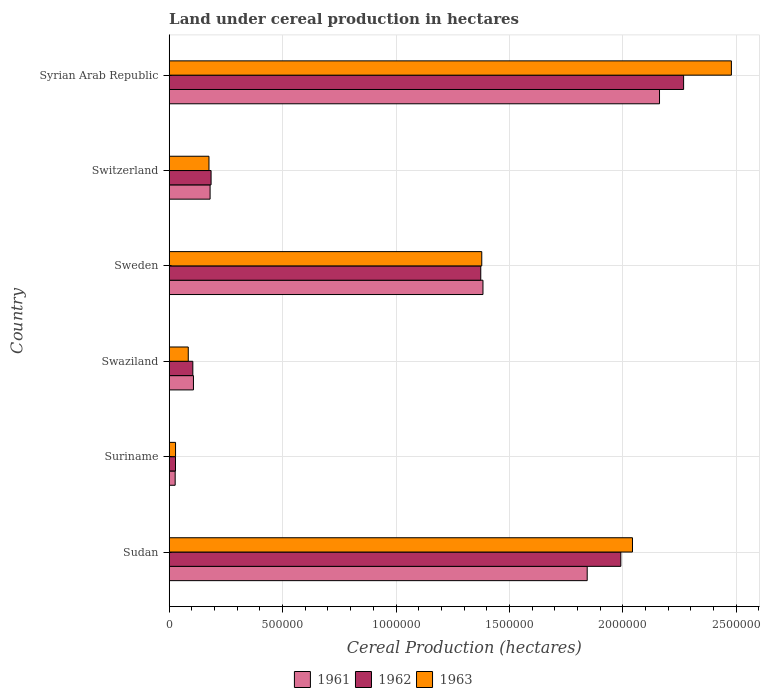How many groups of bars are there?
Give a very brief answer. 6. How many bars are there on the 4th tick from the bottom?
Offer a terse response. 3. What is the label of the 3rd group of bars from the top?
Provide a short and direct response. Sweden. What is the land under cereal production in 1963 in Suriname?
Offer a terse response. 2.79e+04. Across all countries, what is the maximum land under cereal production in 1962?
Make the answer very short. 2.27e+06. Across all countries, what is the minimum land under cereal production in 1963?
Make the answer very short. 2.79e+04. In which country was the land under cereal production in 1963 maximum?
Offer a very short reply. Syrian Arab Republic. In which country was the land under cereal production in 1963 minimum?
Give a very brief answer. Suriname. What is the total land under cereal production in 1963 in the graph?
Give a very brief answer. 6.19e+06. What is the difference between the land under cereal production in 1961 in Sweden and that in Switzerland?
Provide a succinct answer. 1.20e+06. What is the difference between the land under cereal production in 1962 in Syrian Arab Republic and the land under cereal production in 1963 in Sweden?
Offer a terse response. 8.90e+05. What is the average land under cereal production in 1961 per country?
Provide a succinct answer. 9.50e+05. What is the difference between the land under cereal production in 1961 and land under cereal production in 1963 in Suriname?
Give a very brief answer. -1608. In how many countries, is the land under cereal production in 1962 greater than 2000000 hectares?
Your response must be concise. 1. What is the ratio of the land under cereal production in 1962 in Swaziland to that in Syrian Arab Republic?
Keep it short and to the point. 0.05. Is the difference between the land under cereal production in 1961 in Sudan and Sweden greater than the difference between the land under cereal production in 1963 in Sudan and Sweden?
Provide a succinct answer. No. What is the difference between the highest and the second highest land under cereal production in 1961?
Offer a terse response. 3.19e+05. What is the difference between the highest and the lowest land under cereal production in 1961?
Give a very brief answer. 2.14e+06. In how many countries, is the land under cereal production in 1962 greater than the average land under cereal production in 1962 taken over all countries?
Your answer should be compact. 3. What does the 2nd bar from the top in Syrian Arab Republic represents?
Give a very brief answer. 1962. What does the 1st bar from the bottom in Syrian Arab Republic represents?
Your answer should be very brief. 1961. Is it the case that in every country, the sum of the land under cereal production in 1963 and land under cereal production in 1962 is greater than the land under cereal production in 1961?
Provide a succinct answer. Yes. Are all the bars in the graph horizontal?
Provide a short and direct response. Yes. Are the values on the major ticks of X-axis written in scientific E-notation?
Keep it short and to the point. No. Does the graph contain grids?
Make the answer very short. Yes. What is the title of the graph?
Make the answer very short. Land under cereal production in hectares. What is the label or title of the X-axis?
Offer a very short reply. Cereal Production (hectares). What is the label or title of the Y-axis?
Your response must be concise. Country. What is the Cereal Production (hectares) in 1961 in Sudan?
Ensure brevity in your answer.  1.84e+06. What is the Cereal Production (hectares) in 1962 in Sudan?
Your answer should be compact. 1.99e+06. What is the Cereal Production (hectares) of 1963 in Sudan?
Offer a terse response. 2.04e+06. What is the Cereal Production (hectares) of 1961 in Suriname?
Provide a short and direct response. 2.63e+04. What is the Cereal Production (hectares) in 1962 in Suriname?
Provide a short and direct response. 2.77e+04. What is the Cereal Production (hectares) of 1963 in Suriname?
Ensure brevity in your answer.  2.79e+04. What is the Cereal Production (hectares) of 1961 in Swaziland?
Your answer should be very brief. 1.07e+05. What is the Cereal Production (hectares) of 1962 in Swaziland?
Keep it short and to the point. 1.04e+05. What is the Cereal Production (hectares) in 1963 in Swaziland?
Your answer should be compact. 8.40e+04. What is the Cereal Production (hectares) of 1961 in Sweden?
Ensure brevity in your answer.  1.38e+06. What is the Cereal Production (hectares) of 1962 in Sweden?
Give a very brief answer. 1.37e+06. What is the Cereal Production (hectares) in 1963 in Sweden?
Offer a terse response. 1.38e+06. What is the Cereal Production (hectares) of 1961 in Switzerland?
Make the answer very short. 1.80e+05. What is the Cereal Production (hectares) of 1962 in Switzerland?
Keep it short and to the point. 1.85e+05. What is the Cereal Production (hectares) of 1963 in Switzerland?
Give a very brief answer. 1.75e+05. What is the Cereal Production (hectares) in 1961 in Syrian Arab Republic?
Your answer should be compact. 2.16e+06. What is the Cereal Production (hectares) in 1962 in Syrian Arab Republic?
Keep it short and to the point. 2.27e+06. What is the Cereal Production (hectares) of 1963 in Syrian Arab Republic?
Give a very brief answer. 2.48e+06. Across all countries, what is the maximum Cereal Production (hectares) of 1961?
Give a very brief answer. 2.16e+06. Across all countries, what is the maximum Cereal Production (hectares) of 1962?
Your answer should be compact. 2.27e+06. Across all countries, what is the maximum Cereal Production (hectares) in 1963?
Make the answer very short. 2.48e+06. Across all countries, what is the minimum Cereal Production (hectares) in 1961?
Ensure brevity in your answer.  2.63e+04. Across all countries, what is the minimum Cereal Production (hectares) in 1962?
Keep it short and to the point. 2.77e+04. Across all countries, what is the minimum Cereal Production (hectares) of 1963?
Your answer should be compact. 2.79e+04. What is the total Cereal Production (hectares) in 1961 in the graph?
Provide a succinct answer. 5.70e+06. What is the total Cereal Production (hectares) of 1962 in the graph?
Your answer should be very brief. 5.95e+06. What is the total Cereal Production (hectares) in 1963 in the graph?
Provide a succinct answer. 6.19e+06. What is the difference between the Cereal Production (hectares) of 1961 in Sudan and that in Suriname?
Offer a terse response. 1.82e+06. What is the difference between the Cereal Production (hectares) of 1962 in Sudan and that in Suriname?
Make the answer very short. 1.96e+06. What is the difference between the Cereal Production (hectares) in 1963 in Sudan and that in Suriname?
Offer a very short reply. 2.01e+06. What is the difference between the Cereal Production (hectares) in 1961 in Sudan and that in Swaziland?
Offer a very short reply. 1.74e+06. What is the difference between the Cereal Production (hectares) in 1962 in Sudan and that in Swaziland?
Your answer should be compact. 1.89e+06. What is the difference between the Cereal Production (hectares) in 1963 in Sudan and that in Swaziland?
Ensure brevity in your answer.  1.96e+06. What is the difference between the Cereal Production (hectares) of 1961 in Sudan and that in Sweden?
Give a very brief answer. 4.60e+05. What is the difference between the Cereal Production (hectares) of 1962 in Sudan and that in Sweden?
Give a very brief answer. 6.18e+05. What is the difference between the Cereal Production (hectares) in 1963 in Sudan and that in Sweden?
Keep it short and to the point. 6.65e+05. What is the difference between the Cereal Production (hectares) of 1961 in Sudan and that in Switzerland?
Offer a terse response. 1.66e+06. What is the difference between the Cereal Production (hectares) of 1962 in Sudan and that in Switzerland?
Provide a succinct answer. 1.81e+06. What is the difference between the Cereal Production (hectares) in 1963 in Sudan and that in Switzerland?
Your answer should be very brief. 1.87e+06. What is the difference between the Cereal Production (hectares) of 1961 in Sudan and that in Syrian Arab Republic?
Your answer should be very brief. -3.19e+05. What is the difference between the Cereal Production (hectares) in 1962 in Sudan and that in Syrian Arab Republic?
Your answer should be compact. -2.77e+05. What is the difference between the Cereal Production (hectares) of 1963 in Sudan and that in Syrian Arab Republic?
Offer a terse response. -4.36e+05. What is the difference between the Cereal Production (hectares) in 1961 in Suriname and that in Swaziland?
Offer a very short reply. -8.06e+04. What is the difference between the Cereal Production (hectares) of 1962 in Suriname and that in Swaziland?
Your answer should be very brief. -7.64e+04. What is the difference between the Cereal Production (hectares) of 1963 in Suriname and that in Swaziland?
Offer a terse response. -5.61e+04. What is the difference between the Cereal Production (hectares) in 1961 in Suriname and that in Sweden?
Your answer should be very brief. -1.36e+06. What is the difference between the Cereal Production (hectares) of 1962 in Suriname and that in Sweden?
Provide a short and direct response. -1.35e+06. What is the difference between the Cereal Production (hectares) of 1963 in Suriname and that in Sweden?
Offer a very short reply. -1.35e+06. What is the difference between the Cereal Production (hectares) in 1961 in Suriname and that in Switzerland?
Offer a terse response. -1.54e+05. What is the difference between the Cereal Production (hectares) in 1962 in Suriname and that in Switzerland?
Your answer should be very brief. -1.57e+05. What is the difference between the Cereal Production (hectares) of 1963 in Suriname and that in Switzerland?
Make the answer very short. -1.47e+05. What is the difference between the Cereal Production (hectares) of 1961 in Suriname and that in Syrian Arab Republic?
Provide a succinct answer. -2.14e+06. What is the difference between the Cereal Production (hectares) in 1962 in Suriname and that in Syrian Arab Republic?
Ensure brevity in your answer.  -2.24e+06. What is the difference between the Cereal Production (hectares) of 1963 in Suriname and that in Syrian Arab Republic?
Make the answer very short. -2.45e+06. What is the difference between the Cereal Production (hectares) of 1961 in Swaziland and that in Sweden?
Provide a short and direct response. -1.28e+06. What is the difference between the Cereal Production (hectares) in 1962 in Swaziland and that in Sweden?
Make the answer very short. -1.27e+06. What is the difference between the Cereal Production (hectares) in 1963 in Swaziland and that in Sweden?
Keep it short and to the point. -1.29e+06. What is the difference between the Cereal Production (hectares) of 1961 in Swaziland and that in Switzerland?
Offer a terse response. -7.34e+04. What is the difference between the Cereal Production (hectares) of 1962 in Swaziland and that in Switzerland?
Give a very brief answer. -8.05e+04. What is the difference between the Cereal Production (hectares) in 1963 in Swaziland and that in Switzerland?
Ensure brevity in your answer.  -9.13e+04. What is the difference between the Cereal Production (hectares) of 1961 in Swaziland and that in Syrian Arab Republic?
Provide a short and direct response. -2.05e+06. What is the difference between the Cereal Production (hectares) in 1962 in Swaziland and that in Syrian Arab Republic?
Keep it short and to the point. -2.16e+06. What is the difference between the Cereal Production (hectares) in 1963 in Swaziland and that in Syrian Arab Republic?
Provide a succinct answer. -2.39e+06. What is the difference between the Cereal Production (hectares) of 1961 in Sweden and that in Switzerland?
Provide a short and direct response. 1.20e+06. What is the difference between the Cereal Production (hectares) of 1962 in Sweden and that in Switzerland?
Give a very brief answer. 1.19e+06. What is the difference between the Cereal Production (hectares) of 1963 in Sweden and that in Switzerland?
Make the answer very short. 1.20e+06. What is the difference between the Cereal Production (hectares) of 1961 in Sweden and that in Syrian Arab Republic?
Provide a succinct answer. -7.78e+05. What is the difference between the Cereal Production (hectares) in 1962 in Sweden and that in Syrian Arab Republic?
Provide a short and direct response. -8.94e+05. What is the difference between the Cereal Production (hectares) of 1963 in Sweden and that in Syrian Arab Republic?
Offer a very short reply. -1.10e+06. What is the difference between the Cereal Production (hectares) in 1961 in Switzerland and that in Syrian Arab Republic?
Your answer should be very brief. -1.98e+06. What is the difference between the Cereal Production (hectares) in 1962 in Switzerland and that in Syrian Arab Republic?
Provide a succinct answer. -2.08e+06. What is the difference between the Cereal Production (hectares) in 1963 in Switzerland and that in Syrian Arab Republic?
Offer a very short reply. -2.30e+06. What is the difference between the Cereal Production (hectares) in 1961 in Sudan and the Cereal Production (hectares) in 1962 in Suriname?
Provide a short and direct response. 1.82e+06. What is the difference between the Cereal Production (hectares) in 1961 in Sudan and the Cereal Production (hectares) in 1963 in Suriname?
Provide a short and direct response. 1.82e+06. What is the difference between the Cereal Production (hectares) in 1962 in Sudan and the Cereal Production (hectares) in 1963 in Suriname?
Offer a terse response. 1.96e+06. What is the difference between the Cereal Production (hectares) of 1961 in Sudan and the Cereal Production (hectares) of 1962 in Swaziland?
Give a very brief answer. 1.74e+06. What is the difference between the Cereal Production (hectares) of 1961 in Sudan and the Cereal Production (hectares) of 1963 in Swaziland?
Provide a succinct answer. 1.76e+06. What is the difference between the Cereal Production (hectares) of 1962 in Sudan and the Cereal Production (hectares) of 1963 in Swaziland?
Your answer should be compact. 1.91e+06. What is the difference between the Cereal Production (hectares) in 1961 in Sudan and the Cereal Production (hectares) in 1962 in Sweden?
Provide a succinct answer. 4.69e+05. What is the difference between the Cereal Production (hectares) of 1961 in Sudan and the Cereal Production (hectares) of 1963 in Sweden?
Give a very brief answer. 4.65e+05. What is the difference between the Cereal Production (hectares) in 1962 in Sudan and the Cereal Production (hectares) in 1963 in Sweden?
Provide a short and direct response. 6.13e+05. What is the difference between the Cereal Production (hectares) of 1961 in Sudan and the Cereal Production (hectares) of 1962 in Switzerland?
Ensure brevity in your answer.  1.66e+06. What is the difference between the Cereal Production (hectares) of 1961 in Sudan and the Cereal Production (hectares) of 1963 in Switzerland?
Give a very brief answer. 1.67e+06. What is the difference between the Cereal Production (hectares) of 1962 in Sudan and the Cereal Production (hectares) of 1963 in Switzerland?
Offer a terse response. 1.82e+06. What is the difference between the Cereal Production (hectares) of 1961 in Sudan and the Cereal Production (hectares) of 1962 in Syrian Arab Republic?
Provide a succinct answer. -4.25e+05. What is the difference between the Cereal Production (hectares) in 1961 in Sudan and the Cereal Production (hectares) in 1963 in Syrian Arab Republic?
Your answer should be compact. -6.36e+05. What is the difference between the Cereal Production (hectares) of 1962 in Sudan and the Cereal Production (hectares) of 1963 in Syrian Arab Republic?
Make the answer very short. -4.87e+05. What is the difference between the Cereal Production (hectares) in 1961 in Suriname and the Cereal Production (hectares) in 1962 in Swaziland?
Provide a succinct answer. -7.78e+04. What is the difference between the Cereal Production (hectares) in 1961 in Suriname and the Cereal Production (hectares) in 1963 in Swaziland?
Your answer should be compact. -5.77e+04. What is the difference between the Cereal Production (hectares) of 1962 in Suriname and the Cereal Production (hectares) of 1963 in Swaziland?
Keep it short and to the point. -5.63e+04. What is the difference between the Cereal Production (hectares) in 1961 in Suriname and the Cereal Production (hectares) in 1962 in Sweden?
Give a very brief answer. -1.35e+06. What is the difference between the Cereal Production (hectares) of 1961 in Suriname and the Cereal Production (hectares) of 1963 in Sweden?
Provide a succinct answer. -1.35e+06. What is the difference between the Cereal Production (hectares) in 1962 in Suriname and the Cereal Production (hectares) in 1963 in Sweden?
Give a very brief answer. -1.35e+06. What is the difference between the Cereal Production (hectares) of 1961 in Suriname and the Cereal Production (hectares) of 1962 in Switzerland?
Make the answer very short. -1.58e+05. What is the difference between the Cereal Production (hectares) of 1961 in Suriname and the Cereal Production (hectares) of 1963 in Switzerland?
Make the answer very short. -1.49e+05. What is the difference between the Cereal Production (hectares) in 1962 in Suriname and the Cereal Production (hectares) in 1963 in Switzerland?
Make the answer very short. -1.48e+05. What is the difference between the Cereal Production (hectares) of 1961 in Suriname and the Cereal Production (hectares) of 1962 in Syrian Arab Republic?
Offer a terse response. -2.24e+06. What is the difference between the Cereal Production (hectares) of 1961 in Suriname and the Cereal Production (hectares) of 1963 in Syrian Arab Republic?
Offer a very short reply. -2.45e+06. What is the difference between the Cereal Production (hectares) of 1962 in Suriname and the Cereal Production (hectares) of 1963 in Syrian Arab Republic?
Your answer should be compact. -2.45e+06. What is the difference between the Cereal Production (hectares) in 1961 in Swaziland and the Cereal Production (hectares) in 1962 in Sweden?
Ensure brevity in your answer.  -1.27e+06. What is the difference between the Cereal Production (hectares) in 1961 in Swaziland and the Cereal Production (hectares) in 1963 in Sweden?
Your response must be concise. -1.27e+06. What is the difference between the Cereal Production (hectares) of 1962 in Swaziland and the Cereal Production (hectares) of 1963 in Sweden?
Your answer should be very brief. -1.27e+06. What is the difference between the Cereal Production (hectares) of 1961 in Swaziland and the Cereal Production (hectares) of 1962 in Switzerland?
Give a very brief answer. -7.77e+04. What is the difference between the Cereal Production (hectares) of 1961 in Swaziland and the Cereal Production (hectares) of 1963 in Switzerland?
Give a very brief answer. -6.84e+04. What is the difference between the Cereal Production (hectares) in 1962 in Swaziland and the Cereal Production (hectares) in 1963 in Switzerland?
Offer a very short reply. -7.12e+04. What is the difference between the Cereal Production (hectares) in 1961 in Swaziland and the Cereal Production (hectares) in 1962 in Syrian Arab Republic?
Your answer should be very brief. -2.16e+06. What is the difference between the Cereal Production (hectares) in 1961 in Swaziland and the Cereal Production (hectares) in 1963 in Syrian Arab Republic?
Give a very brief answer. -2.37e+06. What is the difference between the Cereal Production (hectares) of 1962 in Swaziland and the Cereal Production (hectares) of 1963 in Syrian Arab Republic?
Provide a succinct answer. -2.37e+06. What is the difference between the Cereal Production (hectares) of 1961 in Sweden and the Cereal Production (hectares) of 1962 in Switzerland?
Make the answer very short. 1.20e+06. What is the difference between the Cereal Production (hectares) of 1961 in Sweden and the Cereal Production (hectares) of 1963 in Switzerland?
Provide a succinct answer. 1.21e+06. What is the difference between the Cereal Production (hectares) in 1962 in Sweden and the Cereal Production (hectares) in 1963 in Switzerland?
Provide a short and direct response. 1.20e+06. What is the difference between the Cereal Production (hectares) in 1961 in Sweden and the Cereal Production (hectares) in 1962 in Syrian Arab Republic?
Provide a short and direct response. -8.85e+05. What is the difference between the Cereal Production (hectares) in 1961 in Sweden and the Cereal Production (hectares) in 1963 in Syrian Arab Republic?
Offer a very short reply. -1.10e+06. What is the difference between the Cereal Production (hectares) in 1962 in Sweden and the Cereal Production (hectares) in 1963 in Syrian Arab Republic?
Ensure brevity in your answer.  -1.10e+06. What is the difference between the Cereal Production (hectares) in 1961 in Switzerland and the Cereal Production (hectares) in 1962 in Syrian Arab Republic?
Provide a short and direct response. -2.09e+06. What is the difference between the Cereal Production (hectares) in 1961 in Switzerland and the Cereal Production (hectares) in 1963 in Syrian Arab Republic?
Keep it short and to the point. -2.30e+06. What is the difference between the Cereal Production (hectares) in 1962 in Switzerland and the Cereal Production (hectares) in 1963 in Syrian Arab Republic?
Keep it short and to the point. -2.29e+06. What is the average Cereal Production (hectares) of 1961 per country?
Your answer should be very brief. 9.50e+05. What is the average Cereal Production (hectares) of 1962 per country?
Make the answer very short. 9.92e+05. What is the average Cereal Production (hectares) of 1963 per country?
Your response must be concise. 1.03e+06. What is the difference between the Cereal Production (hectares) in 1961 and Cereal Production (hectares) in 1962 in Sudan?
Ensure brevity in your answer.  -1.48e+05. What is the difference between the Cereal Production (hectares) in 1961 and Cereal Production (hectares) in 1963 in Sudan?
Ensure brevity in your answer.  -2.00e+05. What is the difference between the Cereal Production (hectares) of 1962 and Cereal Production (hectares) of 1963 in Sudan?
Offer a very short reply. -5.14e+04. What is the difference between the Cereal Production (hectares) in 1961 and Cereal Production (hectares) in 1962 in Suriname?
Keep it short and to the point. -1390. What is the difference between the Cereal Production (hectares) in 1961 and Cereal Production (hectares) in 1963 in Suriname?
Your answer should be compact. -1608. What is the difference between the Cereal Production (hectares) in 1962 and Cereal Production (hectares) in 1963 in Suriname?
Ensure brevity in your answer.  -218. What is the difference between the Cereal Production (hectares) in 1961 and Cereal Production (hectares) in 1962 in Swaziland?
Offer a terse response. 2763. What is the difference between the Cereal Production (hectares) in 1961 and Cereal Production (hectares) in 1963 in Swaziland?
Make the answer very short. 2.29e+04. What is the difference between the Cereal Production (hectares) in 1962 and Cereal Production (hectares) in 1963 in Swaziland?
Ensure brevity in your answer.  2.01e+04. What is the difference between the Cereal Production (hectares) of 1961 and Cereal Production (hectares) of 1962 in Sweden?
Keep it short and to the point. 9669. What is the difference between the Cereal Production (hectares) of 1961 and Cereal Production (hectares) of 1963 in Sweden?
Offer a terse response. 5292. What is the difference between the Cereal Production (hectares) of 1962 and Cereal Production (hectares) of 1963 in Sweden?
Provide a succinct answer. -4377. What is the difference between the Cereal Production (hectares) of 1961 and Cereal Production (hectares) of 1962 in Switzerland?
Ensure brevity in your answer.  -4395. What is the difference between the Cereal Production (hectares) of 1961 and Cereal Production (hectares) of 1963 in Switzerland?
Provide a succinct answer. 4955. What is the difference between the Cereal Production (hectares) of 1962 and Cereal Production (hectares) of 1963 in Switzerland?
Provide a succinct answer. 9350. What is the difference between the Cereal Production (hectares) in 1961 and Cereal Production (hectares) in 1962 in Syrian Arab Republic?
Ensure brevity in your answer.  -1.06e+05. What is the difference between the Cereal Production (hectares) of 1961 and Cereal Production (hectares) of 1963 in Syrian Arab Republic?
Make the answer very short. -3.17e+05. What is the difference between the Cereal Production (hectares) in 1962 and Cereal Production (hectares) in 1963 in Syrian Arab Republic?
Your answer should be compact. -2.11e+05. What is the ratio of the Cereal Production (hectares) of 1961 in Sudan to that in Suriname?
Your response must be concise. 69.97. What is the ratio of the Cereal Production (hectares) of 1962 in Sudan to that in Suriname?
Give a very brief answer. 71.81. What is the ratio of the Cereal Production (hectares) of 1963 in Sudan to that in Suriname?
Your response must be concise. 73.09. What is the ratio of the Cereal Production (hectares) of 1961 in Sudan to that in Swaziland?
Keep it short and to the point. 17.24. What is the ratio of the Cereal Production (hectares) of 1962 in Sudan to that in Swaziland?
Provide a succinct answer. 19.12. What is the ratio of the Cereal Production (hectares) of 1963 in Sudan to that in Swaziland?
Keep it short and to the point. 24.31. What is the ratio of the Cereal Production (hectares) in 1961 in Sudan to that in Sweden?
Give a very brief answer. 1.33. What is the ratio of the Cereal Production (hectares) in 1962 in Sudan to that in Sweden?
Ensure brevity in your answer.  1.45. What is the ratio of the Cereal Production (hectares) of 1963 in Sudan to that in Sweden?
Your answer should be very brief. 1.48. What is the ratio of the Cereal Production (hectares) of 1961 in Sudan to that in Switzerland?
Offer a terse response. 10.22. What is the ratio of the Cereal Production (hectares) in 1962 in Sudan to that in Switzerland?
Offer a very short reply. 10.78. What is the ratio of the Cereal Production (hectares) in 1963 in Sudan to that in Switzerland?
Your answer should be very brief. 11.65. What is the ratio of the Cereal Production (hectares) in 1961 in Sudan to that in Syrian Arab Republic?
Your answer should be compact. 0.85. What is the ratio of the Cereal Production (hectares) in 1962 in Sudan to that in Syrian Arab Republic?
Provide a short and direct response. 0.88. What is the ratio of the Cereal Production (hectares) of 1963 in Sudan to that in Syrian Arab Republic?
Provide a short and direct response. 0.82. What is the ratio of the Cereal Production (hectares) in 1961 in Suriname to that in Swaziland?
Your answer should be compact. 0.25. What is the ratio of the Cereal Production (hectares) in 1962 in Suriname to that in Swaziland?
Your answer should be compact. 0.27. What is the ratio of the Cereal Production (hectares) in 1963 in Suriname to that in Swaziland?
Provide a succinct answer. 0.33. What is the ratio of the Cereal Production (hectares) in 1961 in Suriname to that in Sweden?
Give a very brief answer. 0.02. What is the ratio of the Cereal Production (hectares) of 1962 in Suriname to that in Sweden?
Offer a terse response. 0.02. What is the ratio of the Cereal Production (hectares) of 1963 in Suriname to that in Sweden?
Your response must be concise. 0.02. What is the ratio of the Cereal Production (hectares) of 1961 in Suriname to that in Switzerland?
Your response must be concise. 0.15. What is the ratio of the Cereal Production (hectares) of 1962 in Suriname to that in Switzerland?
Offer a terse response. 0.15. What is the ratio of the Cereal Production (hectares) of 1963 in Suriname to that in Switzerland?
Your answer should be very brief. 0.16. What is the ratio of the Cereal Production (hectares) of 1961 in Suriname to that in Syrian Arab Republic?
Provide a succinct answer. 0.01. What is the ratio of the Cereal Production (hectares) of 1962 in Suriname to that in Syrian Arab Republic?
Offer a very short reply. 0.01. What is the ratio of the Cereal Production (hectares) in 1963 in Suriname to that in Syrian Arab Republic?
Provide a short and direct response. 0.01. What is the ratio of the Cereal Production (hectares) of 1961 in Swaziland to that in Sweden?
Your answer should be very brief. 0.08. What is the ratio of the Cereal Production (hectares) in 1962 in Swaziland to that in Sweden?
Provide a short and direct response. 0.08. What is the ratio of the Cereal Production (hectares) in 1963 in Swaziland to that in Sweden?
Your response must be concise. 0.06. What is the ratio of the Cereal Production (hectares) in 1961 in Swaziland to that in Switzerland?
Make the answer very short. 0.59. What is the ratio of the Cereal Production (hectares) of 1962 in Swaziland to that in Switzerland?
Give a very brief answer. 0.56. What is the ratio of the Cereal Production (hectares) in 1963 in Swaziland to that in Switzerland?
Provide a succinct answer. 0.48. What is the ratio of the Cereal Production (hectares) in 1961 in Swaziland to that in Syrian Arab Republic?
Offer a very short reply. 0.05. What is the ratio of the Cereal Production (hectares) of 1962 in Swaziland to that in Syrian Arab Republic?
Your answer should be compact. 0.05. What is the ratio of the Cereal Production (hectares) of 1963 in Swaziland to that in Syrian Arab Republic?
Offer a terse response. 0.03. What is the ratio of the Cereal Production (hectares) in 1961 in Sweden to that in Switzerland?
Provide a short and direct response. 7.67. What is the ratio of the Cereal Production (hectares) of 1962 in Sweden to that in Switzerland?
Your answer should be very brief. 7.44. What is the ratio of the Cereal Production (hectares) in 1963 in Sweden to that in Switzerland?
Your answer should be very brief. 7.86. What is the ratio of the Cereal Production (hectares) in 1961 in Sweden to that in Syrian Arab Republic?
Keep it short and to the point. 0.64. What is the ratio of the Cereal Production (hectares) of 1962 in Sweden to that in Syrian Arab Republic?
Your answer should be very brief. 0.61. What is the ratio of the Cereal Production (hectares) of 1963 in Sweden to that in Syrian Arab Republic?
Your response must be concise. 0.56. What is the ratio of the Cereal Production (hectares) in 1961 in Switzerland to that in Syrian Arab Republic?
Your response must be concise. 0.08. What is the ratio of the Cereal Production (hectares) of 1962 in Switzerland to that in Syrian Arab Republic?
Your response must be concise. 0.08. What is the ratio of the Cereal Production (hectares) of 1963 in Switzerland to that in Syrian Arab Republic?
Your answer should be very brief. 0.07. What is the difference between the highest and the second highest Cereal Production (hectares) of 1961?
Your answer should be compact. 3.19e+05. What is the difference between the highest and the second highest Cereal Production (hectares) in 1962?
Your answer should be compact. 2.77e+05. What is the difference between the highest and the second highest Cereal Production (hectares) in 1963?
Make the answer very short. 4.36e+05. What is the difference between the highest and the lowest Cereal Production (hectares) in 1961?
Ensure brevity in your answer.  2.14e+06. What is the difference between the highest and the lowest Cereal Production (hectares) in 1962?
Your answer should be very brief. 2.24e+06. What is the difference between the highest and the lowest Cereal Production (hectares) in 1963?
Your answer should be very brief. 2.45e+06. 